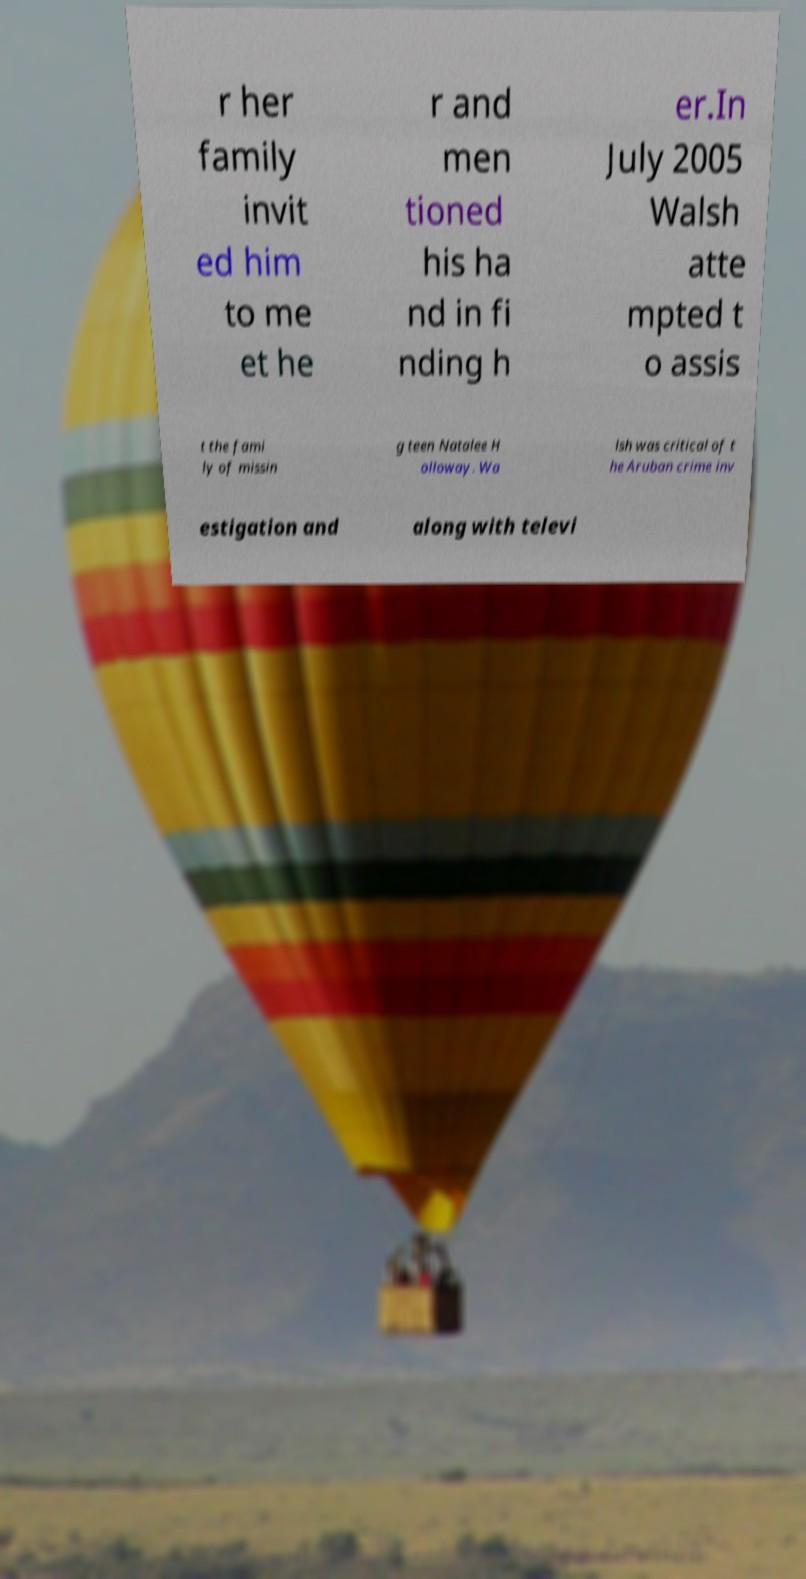Could you extract and type out the text from this image? r her family invit ed him to me et he r and men tioned his ha nd in fi nding h er.In July 2005 Walsh atte mpted t o assis t the fami ly of missin g teen Natalee H olloway. Wa lsh was critical of t he Aruban crime inv estigation and along with televi 